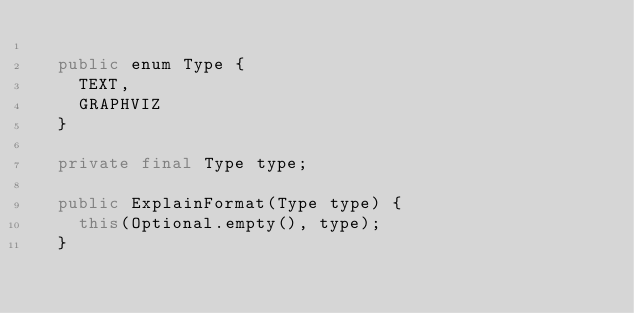<code> <loc_0><loc_0><loc_500><loc_500><_Java_>
  public enum Type {
    TEXT,
    GRAPHVIZ
  }

  private final Type type;

  public ExplainFormat(Type type) {
    this(Optional.empty(), type);
  }
</code> 